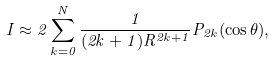Convert formula to latex. <formula><loc_0><loc_0><loc_500><loc_500>I \approx 2 \sum _ { k = 0 } ^ { N } \frac { 1 } { ( 2 k + 1 ) R ^ { 2 k + 1 } } P _ { 2 k } ( \cos \theta ) ,</formula> 